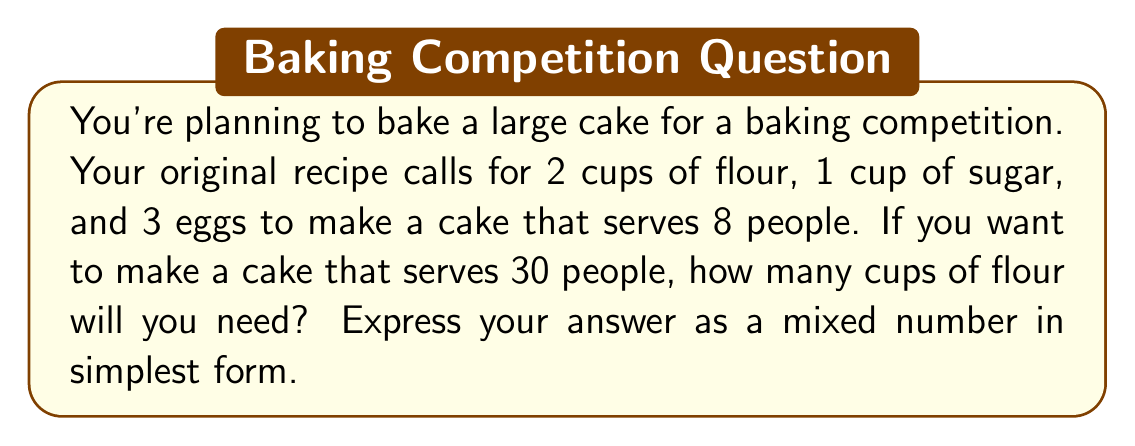Can you answer this question? To solve this problem, we need to determine the ratio of the new serving size to the original serving size and then scale up the ingredients accordingly. Let's break it down step-by-step:

1. Calculate the scaling factor:
   New serving size / Original serving size = $30 / 8 = 3.75$

2. To find the new amount of flour, multiply the original amount by the scaling factor:
   $2 \text{ cups} \times 3.75 = 7.5 \text{ cups}$

3. Express 7.5 as a mixed number:
   $7.5 = 7 \frac{1}{2}$

Therefore, you will need $7 \frac{1}{2}$ cups of flour for the scaled-up recipe.

Note: This same scaling factor can be applied to the other ingredients:
- Sugar: $1 \text{ cup} \times 3.75 = 3.75 \text{ cups} = 3 \frac{3}{4} \text{ cups}$
- Eggs: $3 \times 3.75 = 11.25 \approx 11 \text{ eggs}$ (round down to 11 since you can't use a fraction of an egg)
Answer: $7 \frac{1}{2}$ cups of flour 